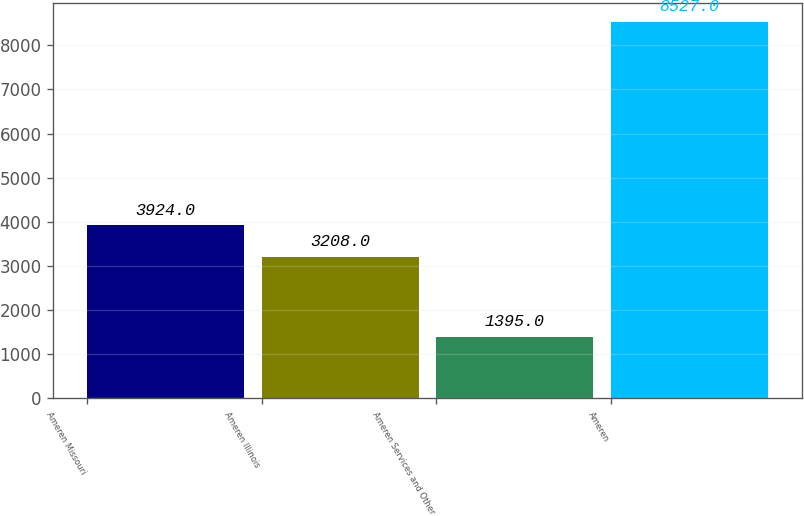Convert chart to OTSL. <chart><loc_0><loc_0><loc_500><loc_500><bar_chart><fcel>Ameren Missouri<fcel>Ameren Illinois<fcel>Ameren Services and Other<fcel>Ameren<nl><fcel>3924<fcel>3208<fcel>1395<fcel>8527<nl></chart> 